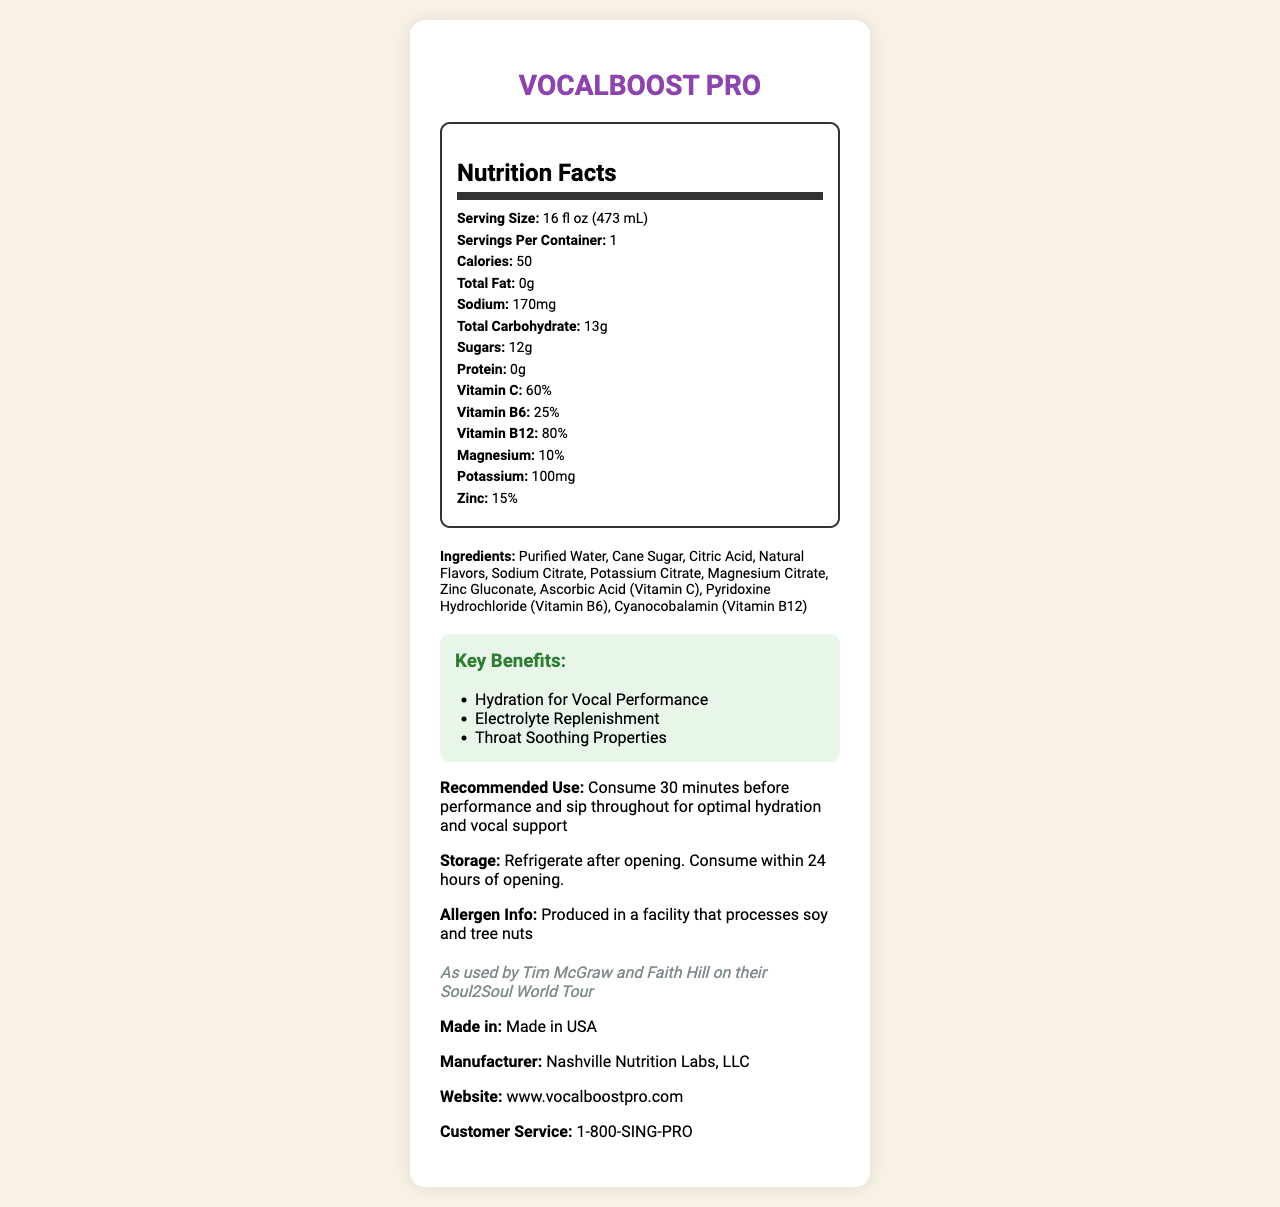what is the serving size for VocalBoost Pro? The document lists the serving size as 16 fl oz (473 mL).
Answer: 16 fl oz (473 mL) how many grams of total carbohydrate are in one serving? According to the nutrition facts, there are 13 grams of total carbohydrate per serving.
Answer: 13g what is the recommended use for this hydration drink? The recommended use section specifies to consume 30 minutes before performance and sip throughout.
Answer: Consume 30 minutes before performance and sip throughout for optimal hydration and vocal support how much sodium is in one serving? The nutrition facts state that there are 170mg of sodium per serving.
Answer: 170mg Does VocalBoost Pro contain protein? The document clearly states that there is 0 grams of protein per serving.
Answer: No which vitamins are included in VocalBoost Pro? The nutrition facts list Vitamin C, Vitamin B6, and Vitamin B12 as included vitamins.
Answer: Vitamin C, Vitamin B6, Vitamin B12 what is the primary flavor of VocalBoost Pro? The document states that the flavor is Honey Lemon.
Answer: Honey Lemon what are the throat-soothing ingredients in the drink? The ingredients listed include "Natural Flavors" and "Citric Acid," which commonly have soothing properties.
Answer: Natural Flavors, Citric Acid how many calories are in one serving? The nutrition facts indicate that there are 50 calories per serving.
Answer: 50 which of the following is NOT listed as a key benefit of VocalBoost Pro? A. Energy Boost B. Hydration for Vocal Performance C. Electrolyte Replenishment D. Throat Soothing Properties Energy Boost is not listed; the benefits mentioned are Hydration for Vocal Performance, Electrolyte Replenishment, and Throat Soothing Properties.
Answer: A. Energy Boost who can be contacted for customer service regarding VocalBoost Pro? The document states that the customer service number is 1-800-SING-PRO.
Answer: 1-800-SING-PRO Was VocalBoost Pro tested on any tours? The document mentions that it was used by Tim McGraw and Faith Hill on their Soul2Soul World Tour.
Answer: Yes what is the manufacturer's name and where is this drink made? The document lists Nashville Nutrition Labs, LLC as the manufacturer and it is made in the USA.
Answer: Nashville Nutrition Labs, LLC, Made in USA summarize the key information provided in the document about VocalBoost Pro. This summary captures the main points about the product's purpose, nutritional content, usage instructions, origin, and manufacturer.
Answer: VocalBoost Pro is a Honey Lemon-flavored hydration drink aimed at performers, providing nutritional and throat-soothing benefits. It contains 50 calories, no fat or protein, 170mg of sodium, 13g of carbohydrates (12g sugars), and essential vitamins such as Vitamin C, B6, and B12. Recommended use is 30 minutes before performance, and refrigeration is needed after opening. The product is made in the USA by Nashville Nutrition Labs and was tested on the Soul2Soul World Tour. How does VocalBoost Pro help with vocal performance? The document does not provide specific details about how the ingredients or nutritional profile directly aid vocal performance.
Answer: Cannot be determined 